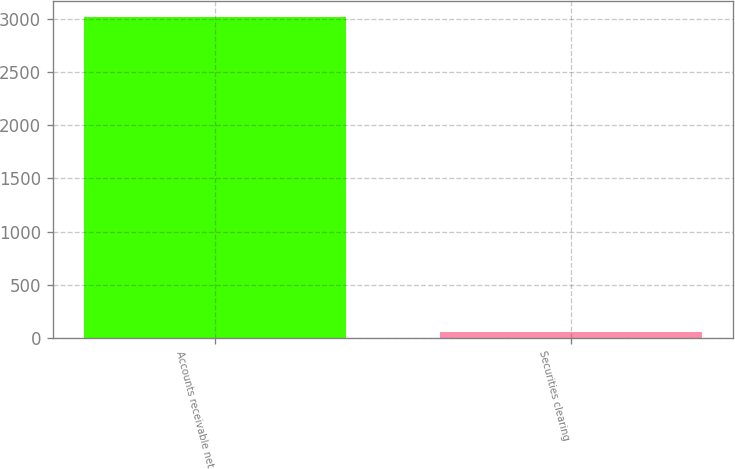Convert chart to OTSL. <chart><loc_0><loc_0><loc_500><loc_500><bar_chart><fcel>Accounts receivable net<fcel>Securities clearing<nl><fcel>3016<fcel>52<nl></chart> 